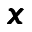<formula> <loc_0><loc_0><loc_500><loc_500>\pm b { x }</formula> 